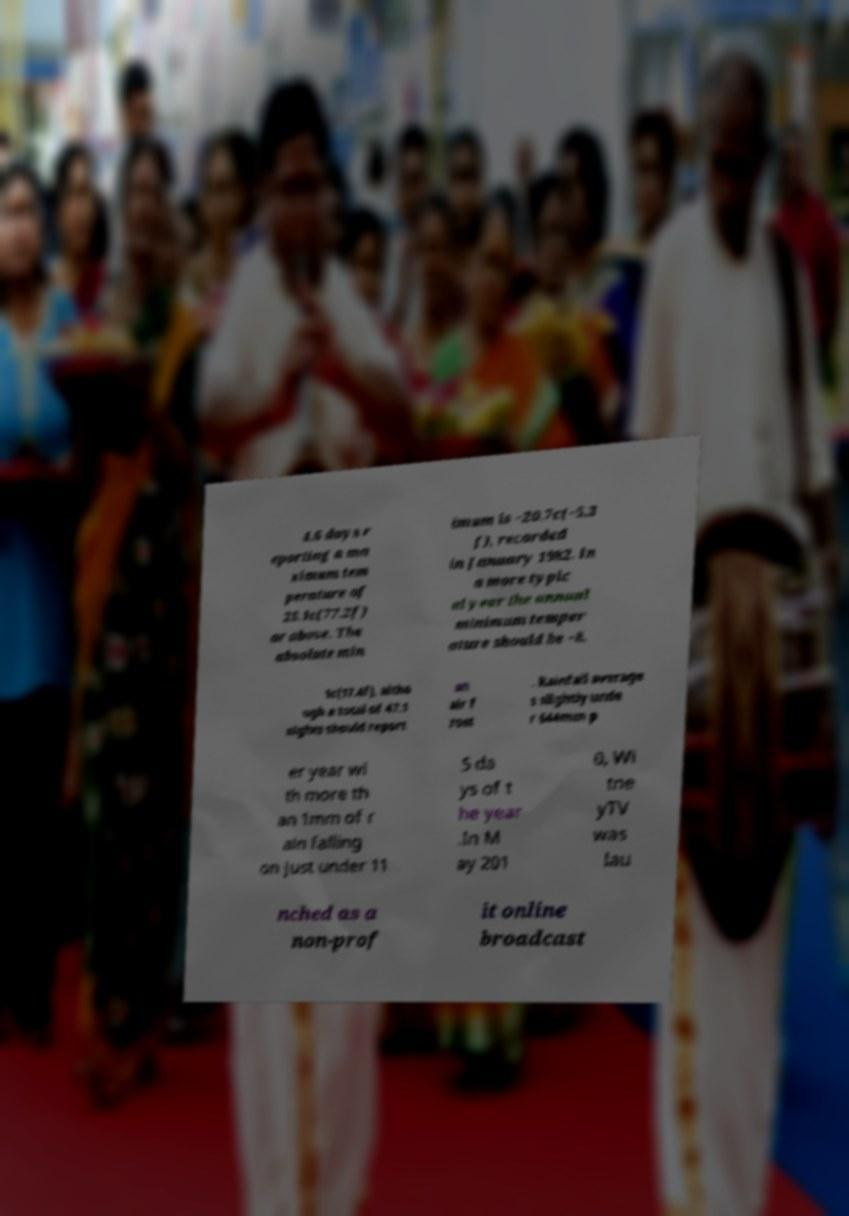Please identify and transcribe the text found in this image. 4.6 days r eporting a ma ximum tem perature of 25.1c(77.2f) or above. The absolute min imum is −20.7c(−5.3 f), recorded in January 1982. In a more typic al year the annual minimum temper ature should be −8. 1c(17.4f), altho ugh a total of 47.1 nights should report an air f rost . Rainfall average s slightly unde r 644mm p er year wi th more th an 1mm of r ain falling on just under 11 5 da ys of t he year .In M ay 201 0, Wi tne yTV was lau nched as a non-prof it online broadcast 